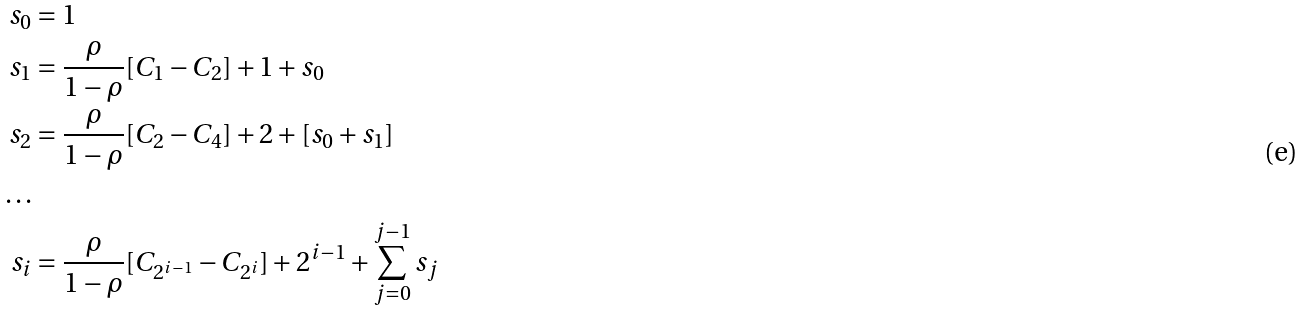<formula> <loc_0><loc_0><loc_500><loc_500>s _ { 0 } & = 1 \\ s _ { 1 } & = \frac { \rho } { 1 - \rho } [ C _ { 1 } - C _ { 2 } ] + 1 + s _ { 0 } \\ s _ { 2 } & = \frac { \rho } { 1 - \rho } [ C _ { 2 } - C _ { 4 } ] + 2 + [ s _ { 0 } + s _ { 1 } ] \\ \dots \\ s _ { i } & = \frac { \rho } { 1 - \rho } [ C _ { 2 ^ { i - 1 } } - C _ { 2 ^ { i } } ] + 2 ^ { i - 1 } + \sum _ { j = 0 } ^ { j - 1 } s _ { j }</formula> 